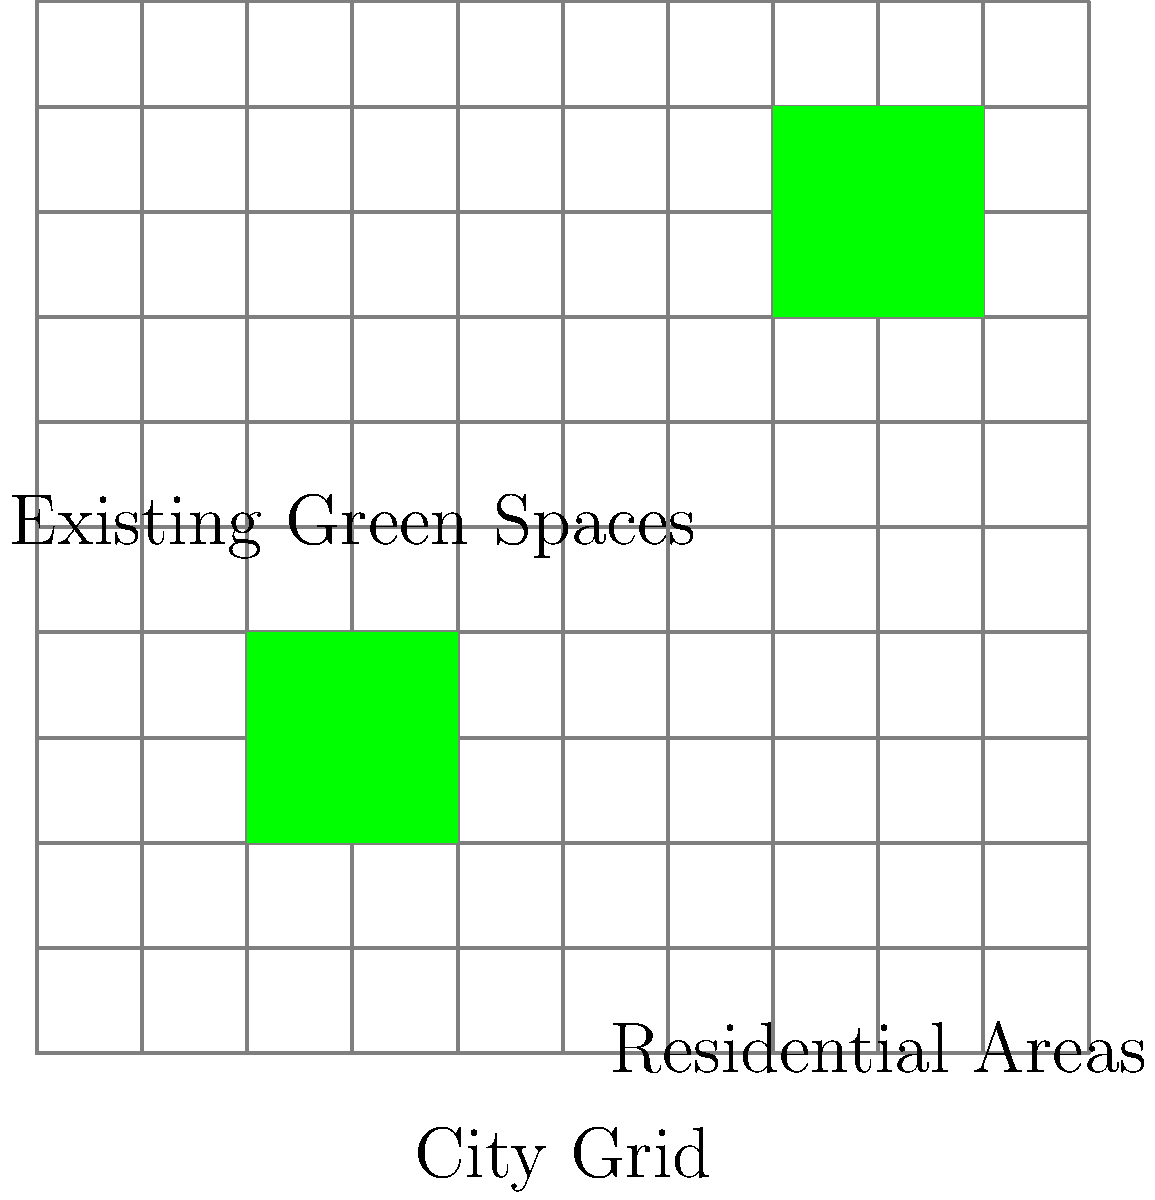Given the urban layout shown in the diagram, where green squares represent existing green spaces and the rest are primarily residential areas, propose a strategy to optimize green space distribution by adding two new green spaces, each 2x2 units in size. Consider factors such as accessibility and even distribution. Where would you place these new green spaces to maximize their benefit to the community? To optimize green space distribution, we need to consider several factors:

1. Even distribution: Ensure green spaces are spread out across the city.
2. Accessibility: Place green spaces where they can be easily reached by residents.
3. Coverage: Maximize the number of residential blocks within close proximity to green spaces.

Step-by-step analysis:

1. Existing green spaces:
   - One in the bottom-left quadrant (2,2) to (4,4)
   - One in the top-right quadrant (7,7) to (9,9)

2. Identify underserved areas:
   - The top-left and bottom-right quadrants lack green spaces

3. Propose new green space locations:
   a. Top-left quadrant: (1,6) to (3,8)
      - This location provides green space access to the northwest area
      - It's not too close to the existing bottom-left green space
   b. Bottom-right quadrant: (6,1) to (8,3)
      - This location serves the southeast area
      - It's well-separated from the existing top-right green space

4. Verify distribution:
   - The four green spaces (two existing and two new) are now roughly evenly distributed across the grid
   - Each quadrant of the city has access to a green space
   - The distances between green spaces are maximized within the constraints

5. Check accessibility:
   - Most residential blocks are now within 2-3 units of a green space
   - The new arrangement provides improved access to green spaces for a larger portion of the population

This strategy optimizes the distribution of green spaces by considering even spacing, accessibility, and coverage of residential areas.
Answer: Place new 2x2 green spaces at (1,6) and (6,1). 